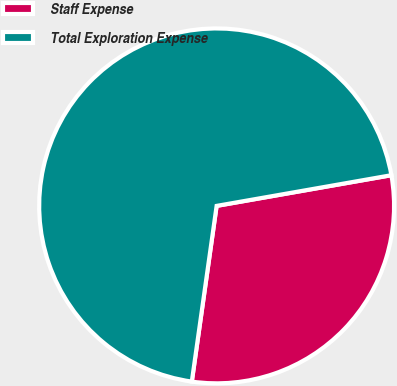<chart> <loc_0><loc_0><loc_500><loc_500><pie_chart><fcel>Staff Expense<fcel>Total Exploration Expense<nl><fcel>30.0%<fcel>70.0%<nl></chart> 